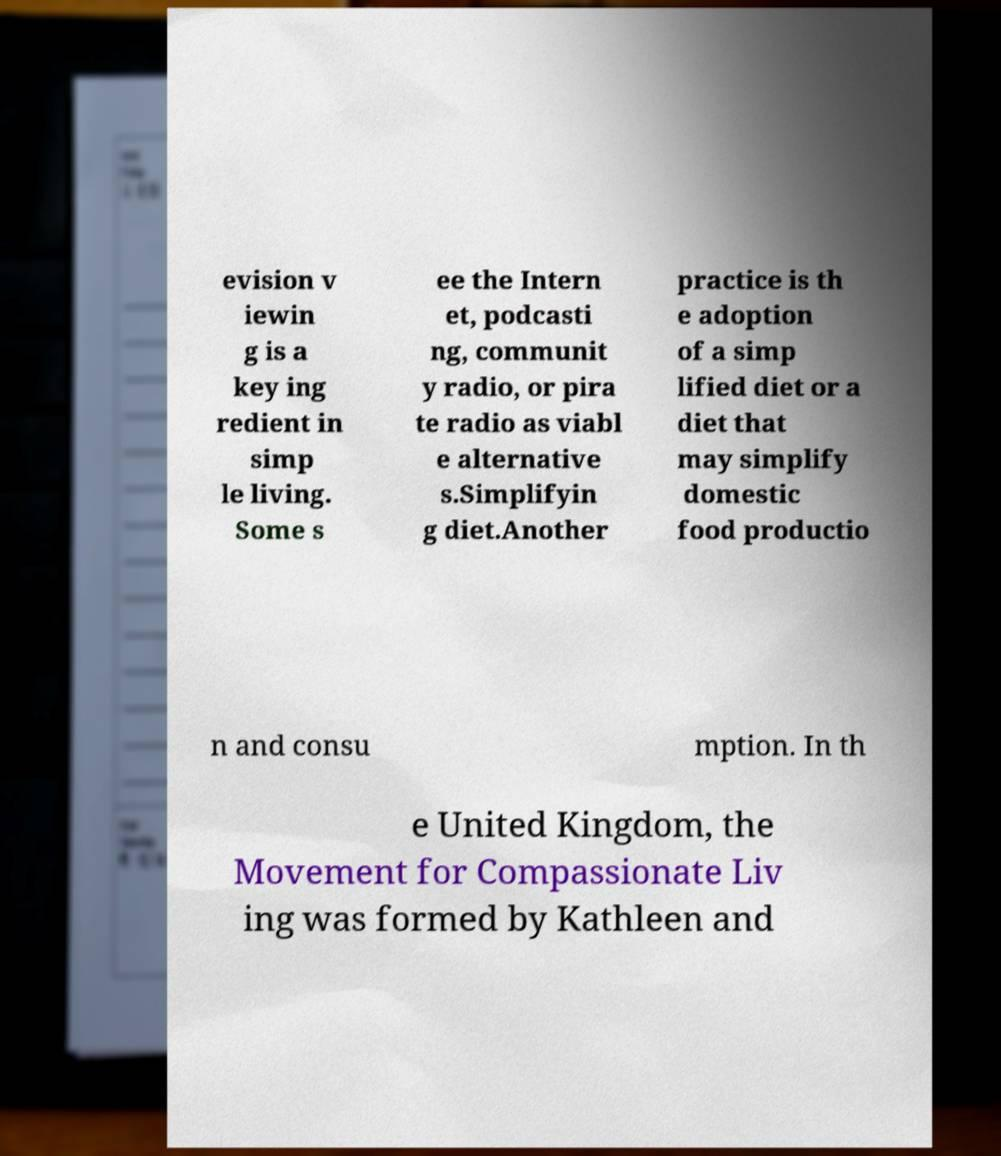Could you extract and type out the text from this image? evision v iewin g is a key ing redient in simp le living. Some s ee the Intern et, podcasti ng, communit y radio, or pira te radio as viabl e alternative s.Simplifyin g diet.Another practice is th e adoption of a simp lified diet or a diet that may simplify domestic food productio n and consu mption. In th e United Kingdom, the Movement for Compassionate Liv ing was formed by Kathleen and 